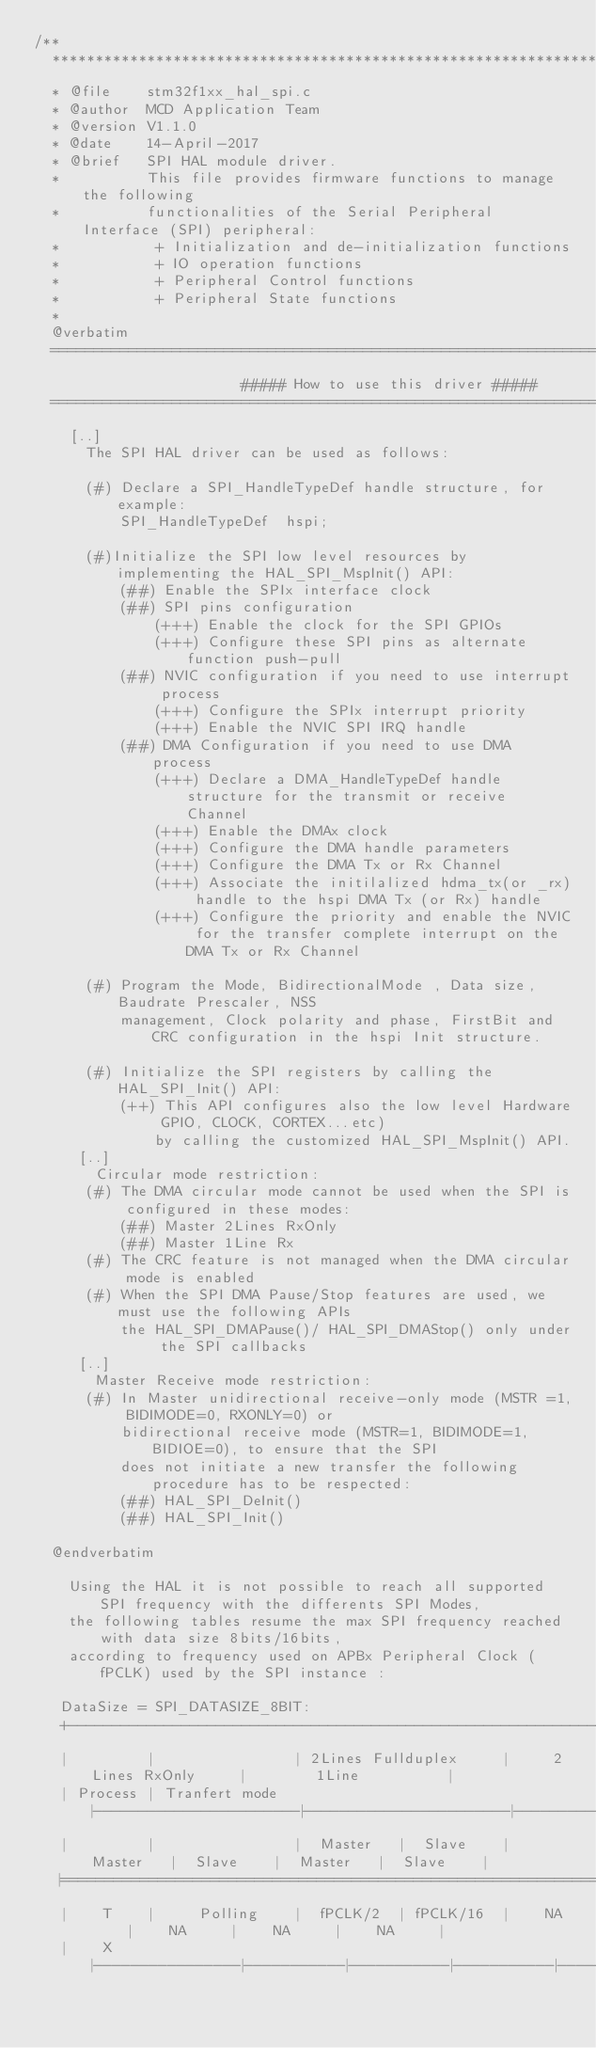Convert code to text. <code><loc_0><loc_0><loc_500><loc_500><_C_>/**
  ******************************************************************************
  * @file    stm32f1xx_hal_spi.c
  * @author  MCD Application Team
  * @version V1.1.0
  * @date    14-April-2017
  * @brief   SPI HAL module driver.
  *          This file provides firmware functions to manage the following
  *          functionalities of the Serial Peripheral Interface (SPI) peripheral:
  *           + Initialization and de-initialization functions
  *           + IO operation functions
  *           + Peripheral Control functions
  *           + Peripheral State functions
  *
  @verbatim
  ==============================================================================
                        ##### How to use this driver #####
  ==============================================================================
    [..]
      The SPI HAL driver can be used as follows:

      (#) Declare a SPI_HandleTypeDef handle structure, for example:
          SPI_HandleTypeDef  hspi;

      (#)Initialize the SPI low level resources by implementing the HAL_SPI_MspInit() API:
          (##) Enable the SPIx interface clock
          (##) SPI pins configuration
              (+++) Enable the clock for the SPI GPIOs
              (+++) Configure these SPI pins as alternate function push-pull
          (##) NVIC configuration if you need to use interrupt process
              (+++) Configure the SPIx interrupt priority
              (+++) Enable the NVIC SPI IRQ handle
          (##) DMA Configuration if you need to use DMA process
              (+++) Declare a DMA_HandleTypeDef handle structure for the transmit or receive Channel
              (+++) Enable the DMAx clock
              (+++) Configure the DMA handle parameters 
              (+++) Configure the DMA Tx or Rx Channel
              (+++) Associate the initilalized hdma_tx(or _rx) handle to the hspi DMA Tx (or Rx) handle
              (+++) Configure the priority and enable the NVIC for the transfer complete interrupt on the DMA Tx or Rx Channel

      (#) Program the Mode, BidirectionalMode , Data size, Baudrate Prescaler, NSS
          management, Clock polarity and phase, FirstBit and CRC configuration in the hspi Init structure.

      (#) Initialize the SPI registers by calling the HAL_SPI_Init() API:
          (++) This API configures also the low level Hardware GPIO, CLOCK, CORTEX...etc)
              by calling the customized HAL_SPI_MspInit() API.
     [..]
       Circular mode restriction:
      (#) The DMA circular mode cannot be used when the SPI is configured in these modes:
          (##) Master 2Lines RxOnly
          (##) Master 1Line Rx
      (#) The CRC feature is not managed when the DMA circular mode is enabled
      (#) When the SPI DMA Pause/Stop features are used, we must use the following APIs
          the HAL_SPI_DMAPause()/ HAL_SPI_DMAStop() only under the SPI callbacks
     [..]
       Master Receive mode restriction:
      (#) In Master unidirectional receive-only mode (MSTR =1, BIDIMODE=0, RXONLY=0) or
          bidirectional receive mode (MSTR=1, BIDIMODE=1, BIDIOE=0), to ensure that the SPI
          does not initiate a new transfer the following procedure has to be respected:
          (##) HAL_SPI_DeInit()
          (##) HAL_SPI_Init()

  @endverbatim

    Using the HAL it is not possible to reach all supported SPI frequency with the differents SPI Modes,
    the following tables resume the max SPI frequency reached with data size 8bits/16bits,
    according to frequency used on APBx Peripheral Clock (fPCLK) used by the SPI instance :
    
   DataSize = SPI_DATASIZE_8BIT:
   +--------------------------------------------------------------------------------------------------+
   |         |                | 2Lines Fullduplex     |     2Lines RxOnly     |        1Line          |
   | Process | Tranfert mode  |-----------------------|-----------------------|-----------------------|
   |         |                |  Master   |  Slave    |  Master   |  Slave    |  Master   |  Slave    |
   |==================================================================================================|
   |    T    |     Polling    |  fPCLK/2  | fPCLK/16  |    NA     |    NA     |    NA     |    NA     |
   |    X    |----------------|-----------|-----------|-----------|-----------|-----------|-----------|</code> 